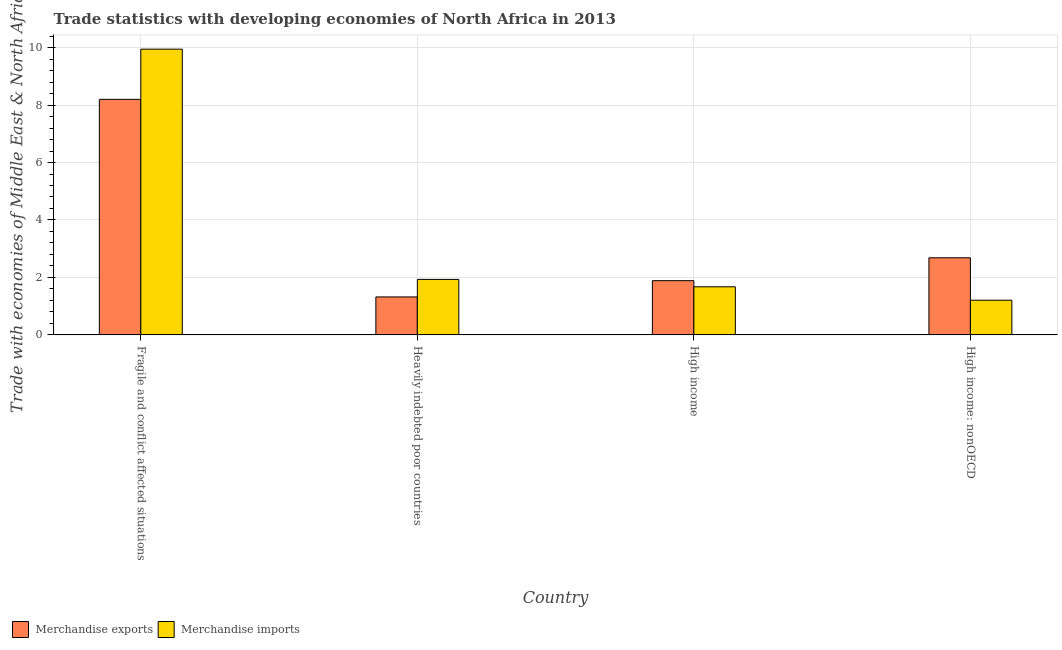How many groups of bars are there?
Offer a very short reply. 4. Are the number of bars per tick equal to the number of legend labels?
Ensure brevity in your answer.  Yes. Are the number of bars on each tick of the X-axis equal?
Keep it short and to the point. Yes. How many bars are there on the 3rd tick from the right?
Your answer should be compact. 2. What is the label of the 1st group of bars from the left?
Provide a succinct answer. Fragile and conflict affected situations. In how many cases, is the number of bars for a given country not equal to the number of legend labels?
Offer a very short reply. 0. What is the merchandise exports in High income: nonOECD?
Your answer should be very brief. 2.68. Across all countries, what is the maximum merchandise imports?
Ensure brevity in your answer.  9.95. Across all countries, what is the minimum merchandise imports?
Offer a very short reply. 1.21. In which country was the merchandise imports maximum?
Provide a short and direct response. Fragile and conflict affected situations. In which country was the merchandise imports minimum?
Ensure brevity in your answer.  High income: nonOECD. What is the total merchandise imports in the graph?
Keep it short and to the point. 14.76. What is the difference between the merchandise imports in Fragile and conflict affected situations and that in High income: nonOECD?
Offer a very short reply. 8.74. What is the difference between the merchandise exports in High income: nonOECD and the merchandise imports in High income?
Provide a succinct answer. 1.01. What is the average merchandise exports per country?
Your response must be concise. 3.52. What is the difference between the merchandise exports and merchandise imports in Fragile and conflict affected situations?
Keep it short and to the point. -1.75. What is the ratio of the merchandise imports in Heavily indebted poor countries to that in High income?
Your answer should be very brief. 1.15. Is the merchandise imports in Heavily indebted poor countries less than that in High income?
Make the answer very short. No. Is the difference between the merchandise exports in Fragile and conflict affected situations and High income: nonOECD greater than the difference between the merchandise imports in Fragile and conflict affected situations and High income: nonOECD?
Make the answer very short. No. What is the difference between the highest and the second highest merchandise imports?
Give a very brief answer. 8.01. What is the difference between the highest and the lowest merchandise exports?
Make the answer very short. 6.88. What does the 2nd bar from the left in High income: nonOECD represents?
Keep it short and to the point. Merchandise imports. What does the 2nd bar from the right in Fragile and conflict affected situations represents?
Keep it short and to the point. Merchandise exports. How many bars are there?
Provide a short and direct response. 8. Are all the bars in the graph horizontal?
Provide a succinct answer. No. How many countries are there in the graph?
Provide a short and direct response. 4. How many legend labels are there?
Keep it short and to the point. 2. How are the legend labels stacked?
Your response must be concise. Horizontal. What is the title of the graph?
Keep it short and to the point. Trade statistics with developing economies of North Africa in 2013. Does "Fertility rate" appear as one of the legend labels in the graph?
Offer a terse response. No. What is the label or title of the X-axis?
Make the answer very short. Country. What is the label or title of the Y-axis?
Offer a very short reply. Trade with economies of Middle East & North Africa(%). What is the Trade with economies of Middle East & North Africa(%) in Merchandise exports in Fragile and conflict affected situations?
Offer a very short reply. 8.2. What is the Trade with economies of Middle East & North Africa(%) of Merchandise imports in Fragile and conflict affected situations?
Keep it short and to the point. 9.95. What is the Trade with economies of Middle East & North Africa(%) in Merchandise exports in Heavily indebted poor countries?
Your response must be concise. 1.32. What is the Trade with economies of Middle East & North Africa(%) of Merchandise imports in Heavily indebted poor countries?
Provide a short and direct response. 1.93. What is the Trade with economies of Middle East & North Africa(%) of Merchandise exports in High income?
Provide a succinct answer. 1.89. What is the Trade with economies of Middle East & North Africa(%) in Merchandise imports in High income?
Your response must be concise. 1.67. What is the Trade with economies of Middle East & North Africa(%) of Merchandise exports in High income: nonOECD?
Your response must be concise. 2.68. What is the Trade with economies of Middle East & North Africa(%) of Merchandise imports in High income: nonOECD?
Give a very brief answer. 1.21. Across all countries, what is the maximum Trade with economies of Middle East & North Africa(%) in Merchandise exports?
Ensure brevity in your answer.  8.2. Across all countries, what is the maximum Trade with economies of Middle East & North Africa(%) in Merchandise imports?
Give a very brief answer. 9.95. Across all countries, what is the minimum Trade with economies of Middle East & North Africa(%) in Merchandise exports?
Offer a terse response. 1.32. Across all countries, what is the minimum Trade with economies of Middle East & North Africa(%) of Merchandise imports?
Offer a terse response. 1.21. What is the total Trade with economies of Middle East & North Africa(%) of Merchandise exports in the graph?
Offer a terse response. 14.09. What is the total Trade with economies of Middle East & North Africa(%) of Merchandise imports in the graph?
Provide a short and direct response. 14.76. What is the difference between the Trade with economies of Middle East & North Africa(%) in Merchandise exports in Fragile and conflict affected situations and that in Heavily indebted poor countries?
Offer a terse response. 6.88. What is the difference between the Trade with economies of Middle East & North Africa(%) in Merchandise imports in Fragile and conflict affected situations and that in Heavily indebted poor countries?
Your answer should be compact. 8.01. What is the difference between the Trade with economies of Middle East & North Africa(%) of Merchandise exports in Fragile and conflict affected situations and that in High income?
Ensure brevity in your answer.  6.31. What is the difference between the Trade with economies of Middle East & North Africa(%) in Merchandise imports in Fragile and conflict affected situations and that in High income?
Ensure brevity in your answer.  8.27. What is the difference between the Trade with economies of Middle East & North Africa(%) in Merchandise exports in Fragile and conflict affected situations and that in High income: nonOECD?
Your response must be concise. 5.52. What is the difference between the Trade with economies of Middle East & North Africa(%) in Merchandise imports in Fragile and conflict affected situations and that in High income: nonOECD?
Your answer should be very brief. 8.74. What is the difference between the Trade with economies of Middle East & North Africa(%) of Merchandise exports in Heavily indebted poor countries and that in High income?
Offer a very short reply. -0.57. What is the difference between the Trade with economies of Middle East & North Africa(%) of Merchandise imports in Heavily indebted poor countries and that in High income?
Your answer should be compact. 0.26. What is the difference between the Trade with economies of Middle East & North Africa(%) of Merchandise exports in Heavily indebted poor countries and that in High income: nonOECD?
Your answer should be compact. -1.36. What is the difference between the Trade with economies of Middle East & North Africa(%) of Merchandise imports in Heavily indebted poor countries and that in High income: nonOECD?
Your answer should be compact. 0.72. What is the difference between the Trade with economies of Middle East & North Africa(%) in Merchandise exports in High income and that in High income: nonOECD?
Provide a succinct answer. -0.8. What is the difference between the Trade with economies of Middle East & North Africa(%) of Merchandise imports in High income and that in High income: nonOECD?
Provide a succinct answer. 0.47. What is the difference between the Trade with economies of Middle East & North Africa(%) in Merchandise exports in Fragile and conflict affected situations and the Trade with economies of Middle East & North Africa(%) in Merchandise imports in Heavily indebted poor countries?
Offer a terse response. 6.27. What is the difference between the Trade with economies of Middle East & North Africa(%) of Merchandise exports in Fragile and conflict affected situations and the Trade with economies of Middle East & North Africa(%) of Merchandise imports in High income?
Provide a succinct answer. 6.52. What is the difference between the Trade with economies of Middle East & North Africa(%) in Merchandise exports in Fragile and conflict affected situations and the Trade with economies of Middle East & North Africa(%) in Merchandise imports in High income: nonOECD?
Your answer should be compact. 6.99. What is the difference between the Trade with economies of Middle East & North Africa(%) of Merchandise exports in Heavily indebted poor countries and the Trade with economies of Middle East & North Africa(%) of Merchandise imports in High income?
Your answer should be very brief. -0.35. What is the difference between the Trade with economies of Middle East & North Africa(%) of Merchandise exports in Heavily indebted poor countries and the Trade with economies of Middle East & North Africa(%) of Merchandise imports in High income: nonOECD?
Offer a terse response. 0.11. What is the difference between the Trade with economies of Middle East & North Africa(%) in Merchandise exports in High income and the Trade with economies of Middle East & North Africa(%) in Merchandise imports in High income: nonOECD?
Ensure brevity in your answer.  0.68. What is the average Trade with economies of Middle East & North Africa(%) of Merchandise exports per country?
Ensure brevity in your answer.  3.52. What is the average Trade with economies of Middle East & North Africa(%) in Merchandise imports per country?
Make the answer very short. 3.69. What is the difference between the Trade with economies of Middle East & North Africa(%) of Merchandise exports and Trade with economies of Middle East & North Africa(%) of Merchandise imports in Fragile and conflict affected situations?
Your answer should be compact. -1.75. What is the difference between the Trade with economies of Middle East & North Africa(%) of Merchandise exports and Trade with economies of Middle East & North Africa(%) of Merchandise imports in Heavily indebted poor countries?
Your answer should be very brief. -0.61. What is the difference between the Trade with economies of Middle East & North Africa(%) in Merchandise exports and Trade with economies of Middle East & North Africa(%) in Merchandise imports in High income?
Keep it short and to the point. 0.21. What is the difference between the Trade with economies of Middle East & North Africa(%) of Merchandise exports and Trade with economies of Middle East & North Africa(%) of Merchandise imports in High income: nonOECD?
Make the answer very short. 1.48. What is the ratio of the Trade with economies of Middle East & North Africa(%) in Merchandise exports in Fragile and conflict affected situations to that in Heavily indebted poor countries?
Make the answer very short. 6.2. What is the ratio of the Trade with economies of Middle East & North Africa(%) in Merchandise imports in Fragile and conflict affected situations to that in Heavily indebted poor countries?
Offer a very short reply. 5.15. What is the ratio of the Trade with economies of Middle East & North Africa(%) in Merchandise exports in Fragile and conflict affected situations to that in High income?
Make the answer very short. 4.34. What is the ratio of the Trade with economies of Middle East & North Africa(%) in Merchandise imports in Fragile and conflict affected situations to that in High income?
Your response must be concise. 5.94. What is the ratio of the Trade with economies of Middle East & North Africa(%) in Merchandise exports in Fragile and conflict affected situations to that in High income: nonOECD?
Make the answer very short. 3.06. What is the ratio of the Trade with economies of Middle East & North Africa(%) in Merchandise imports in Fragile and conflict affected situations to that in High income: nonOECD?
Provide a short and direct response. 8.24. What is the ratio of the Trade with economies of Middle East & North Africa(%) in Merchandise exports in Heavily indebted poor countries to that in High income?
Provide a succinct answer. 0.7. What is the ratio of the Trade with economies of Middle East & North Africa(%) in Merchandise imports in Heavily indebted poor countries to that in High income?
Keep it short and to the point. 1.15. What is the ratio of the Trade with economies of Middle East & North Africa(%) of Merchandise exports in Heavily indebted poor countries to that in High income: nonOECD?
Ensure brevity in your answer.  0.49. What is the ratio of the Trade with economies of Middle East & North Africa(%) of Merchandise imports in Heavily indebted poor countries to that in High income: nonOECD?
Offer a very short reply. 1.6. What is the ratio of the Trade with economies of Middle East & North Africa(%) in Merchandise exports in High income to that in High income: nonOECD?
Provide a short and direct response. 0.7. What is the ratio of the Trade with economies of Middle East & North Africa(%) in Merchandise imports in High income to that in High income: nonOECD?
Provide a short and direct response. 1.39. What is the difference between the highest and the second highest Trade with economies of Middle East & North Africa(%) in Merchandise exports?
Your answer should be very brief. 5.52. What is the difference between the highest and the second highest Trade with economies of Middle East & North Africa(%) of Merchandise imports?
Your response must be concise. 8.01. What is the difference between the highest and the lowest Trade with economies of Middle East & North Africa(%) in Merchandise exports?
Your answer should be compact. 6.88. What is the difference between the highest and the lowest Trade with economies of Middle East & North Africa(%) of Merchandise imports?
Your response must be concise. 8.74. 